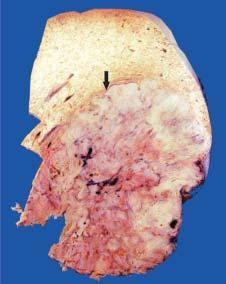does electron microscopy show many nodules of variable sizes owing to co-existent macronodular cirrhosis?
Answer the question using a single word or phrase. No 